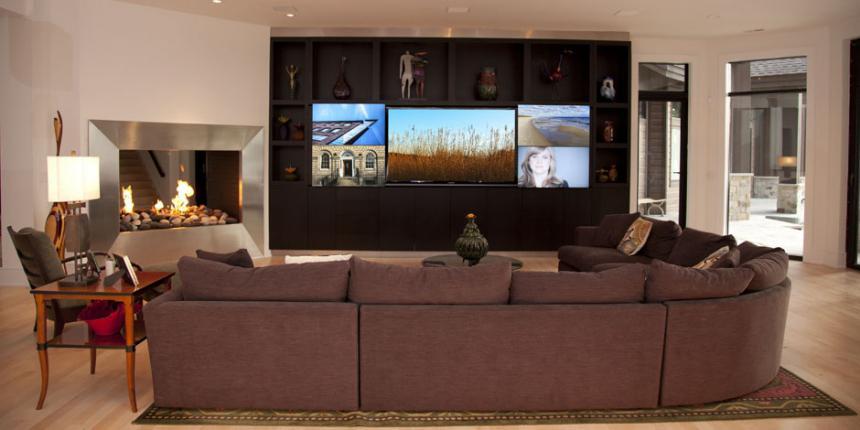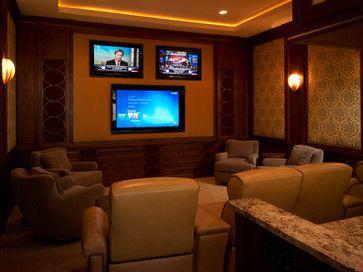The first image is the image on the left, the second image is the image on the right. Evaluate the accuracy of this statement regarding the images: "None of the screens show a basketball game.". Is it true? Answer yes or no. Yes. The first image is the image on the left, the second image is the image on the right. For the images displayed, is the sentence "there are lights haging over the bar" factually correct? Answer yes or no. No. 